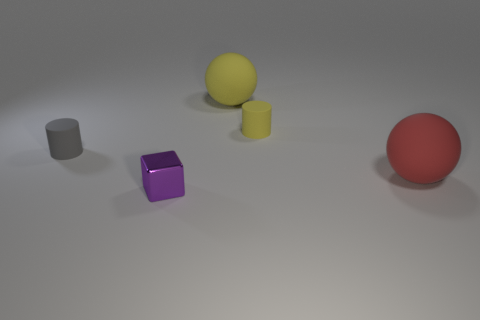There is a small thing that is the same material as the tiny gray cylinder; what color is it?
Offer a terse response. Yellow. How many small yellow things have the same material as the tiny purple cube?
Offer a terse response. 0. There is a large rubber thing in front of the tiny gray thing; is it the same color as the metal thing?
Provide a short and direct response. No. How many yellow objects have the same shape as the large red thing?
Provide a short and direct response. 1. Are there an equal number of small cylinders that are left of the tiny yellow matte cylinder and small green spheres?
Give a very brief answer. No. The other ball that is the same size as the yellow matte ball is what color?
Keep it short and to the point. Red. Is there a small brown rubber thing that has the same shape as the gray matte thing?
Ensure brevity in your answer.  No. What is the material of the thing in front of the sphere that is to the right of the sphere behind the large red matte ball?
Your answer should be very brief. Metal. What number of other objects are there of the same size as the metal thing?
Provide a short and direct response. 2. What is the color of the tiny shiny block?
Your answer should be very brief. Purple. 